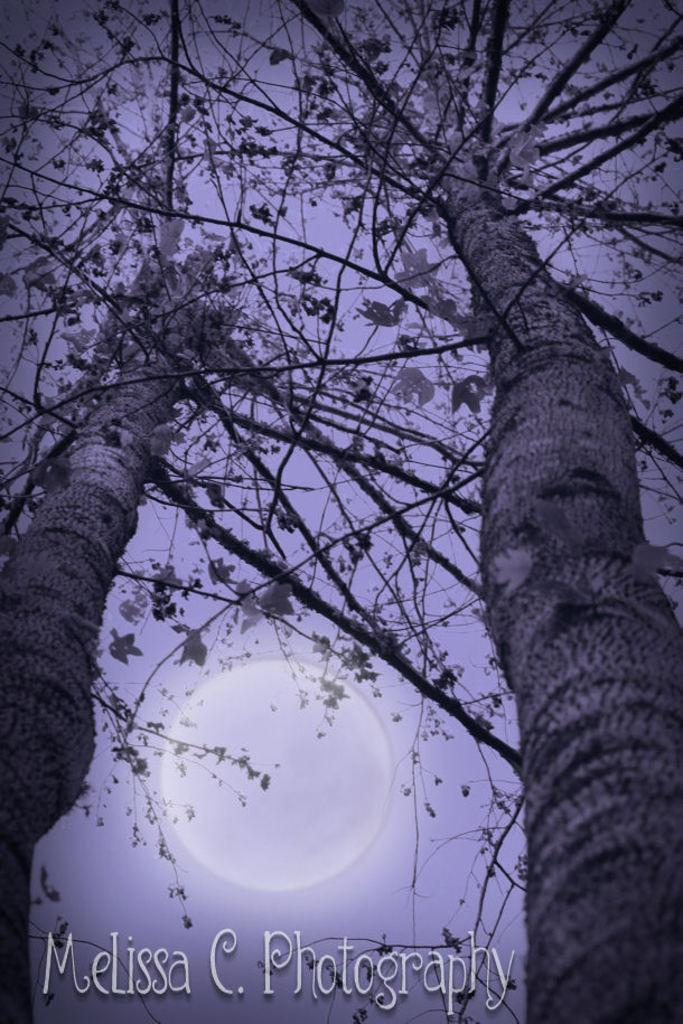What type of vegetation is in the front of the image? There are trees in the front of the image. What part of the natural environment is visible in the background of the image? The sky is visible in the background of the image. Can you describe the celestial body in the sky? The moon is observable in the sky. What type of fang can be seen in the image? There is no fang present in the image. What idea is being conveyed by the trees in the image? The image does not convey any specific ideas; it simply shows trees in the front. 